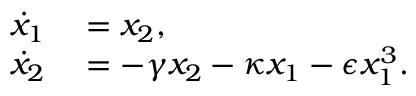Convert formula to latex. <formula><loc_0><loc_0><loc_500><loc_500>\begin{array} { r l } { \dot { x } _ { 1 } } & = x _ { 2 } , } \\ { \dot { x } _ { 2 } } & = - \gamma x _ { 2 } - \kappa x _ { 1 } - \epsilon x _ { 1 } ^ { 3 } . } \end{array}</formula> 